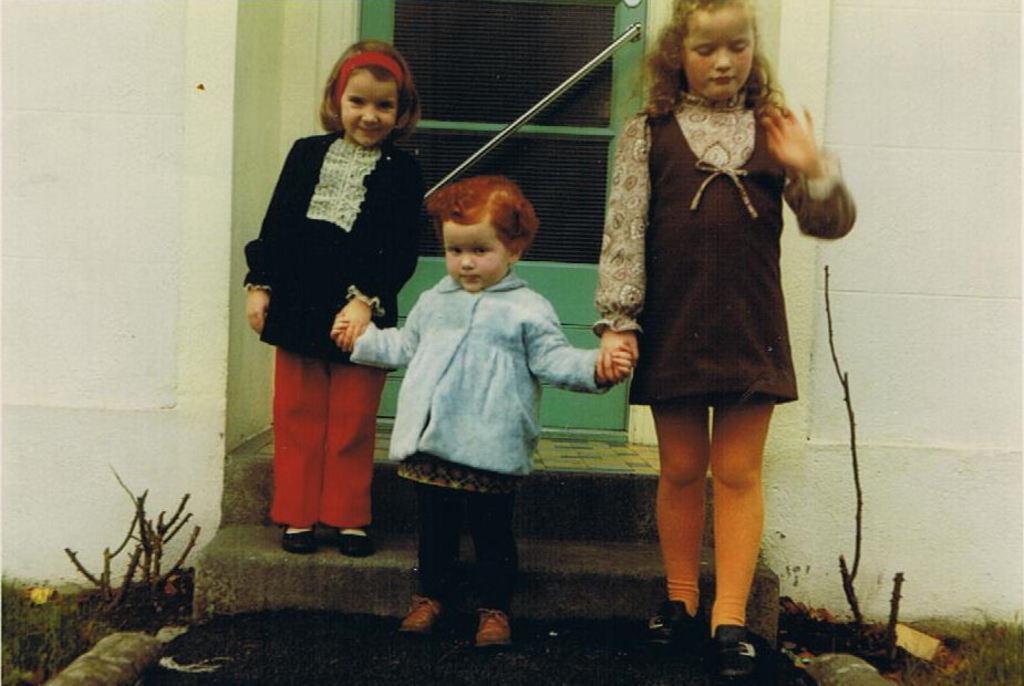Describe this image in one or two sentences. In this picture there is a girl who is wearing blue jacket, trouser and shoe. Beside there is another girl who is wearing a dress and shoe. On the left there is a girl who is wearing band, black dress and shoe. Three of them are standing on the stairs. In the back I can see the door. In the bottom right corner I can see the glass near to the wall. 